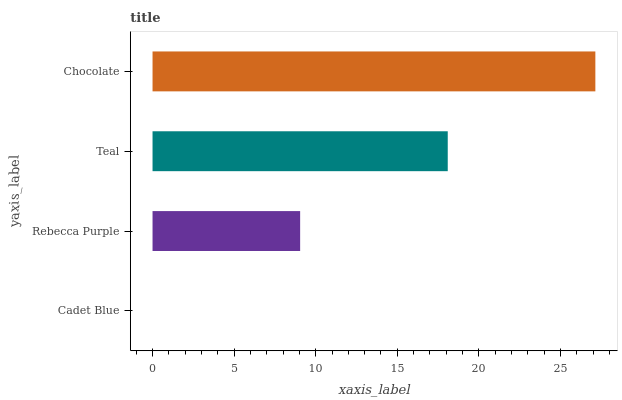Is Cadet Blue the minimum?
Answer yes or no. Yes. Is Chocolate the maximum?
Answer yes or no. Yes. Is Rebecca Purple the minimum?
Answer yes or no. No. Is Rebecca Purple the maximum?
Answer yes or no. No. Is Rebecca Purple greater than Cadet Blue?
Answer yes or no. Yes. Is Cadet Blue less than Rebecca Purple?
Answer yes or no. Yes. Is Cadet Blue greater than Rebecca Purple?
Answer yes or no. No. Is Rebecca Purple less than Cadet Blue?
Answer yes or no. No. Is Teal the high median?
Answer yes or no. Yes. Is Rebecca Purple the low median?
Answer yes or no. Yes. Is Cadet Blue the high median?
Answer yes or no. No. Is Cadet Blue the low median?
Answer yes or no. No. 